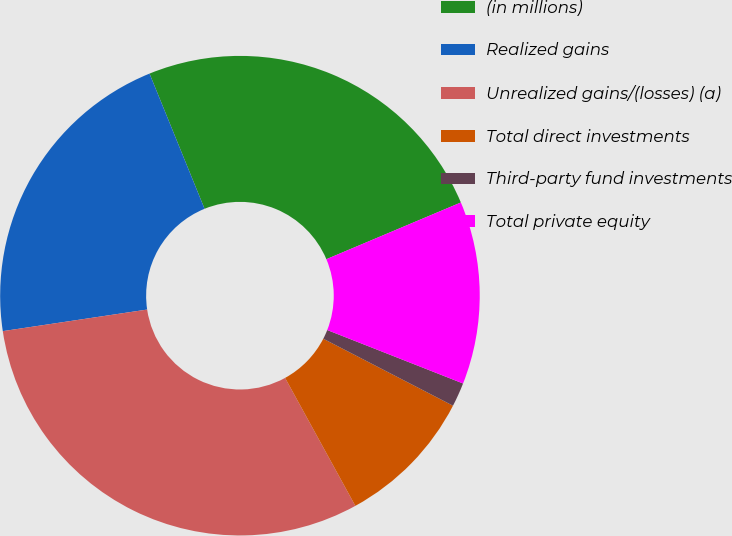Convert chart to OTSL. <chart><loc_0><loc_0><loc_500><loc_500><pie_chart><fcel>(in millions)<fcel>Realized gains<fcel>Unrealized gains/(losses) (a)<fcel>Total direct investments<fcel>Third-party fund investments<fcel>Total private equity<nl><fcel>24.8%<fcel>21.21%<fcel>30.63%<fcel>9.42%<fcel>1.62%<fcel>12.32%<nl></chart> 